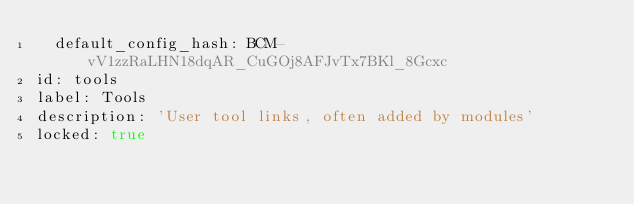<code> <loc_0><loc_0><loc_500><loc_500><_YAML_>  default_config_hash: BCM-vV1zzRaLHN18dqAR_CuGOj8AFJvTx7BKl_8Gcxc
id: tools
label: Tools
description: 'User tool links, often added by modules'
locked: true
</code> 